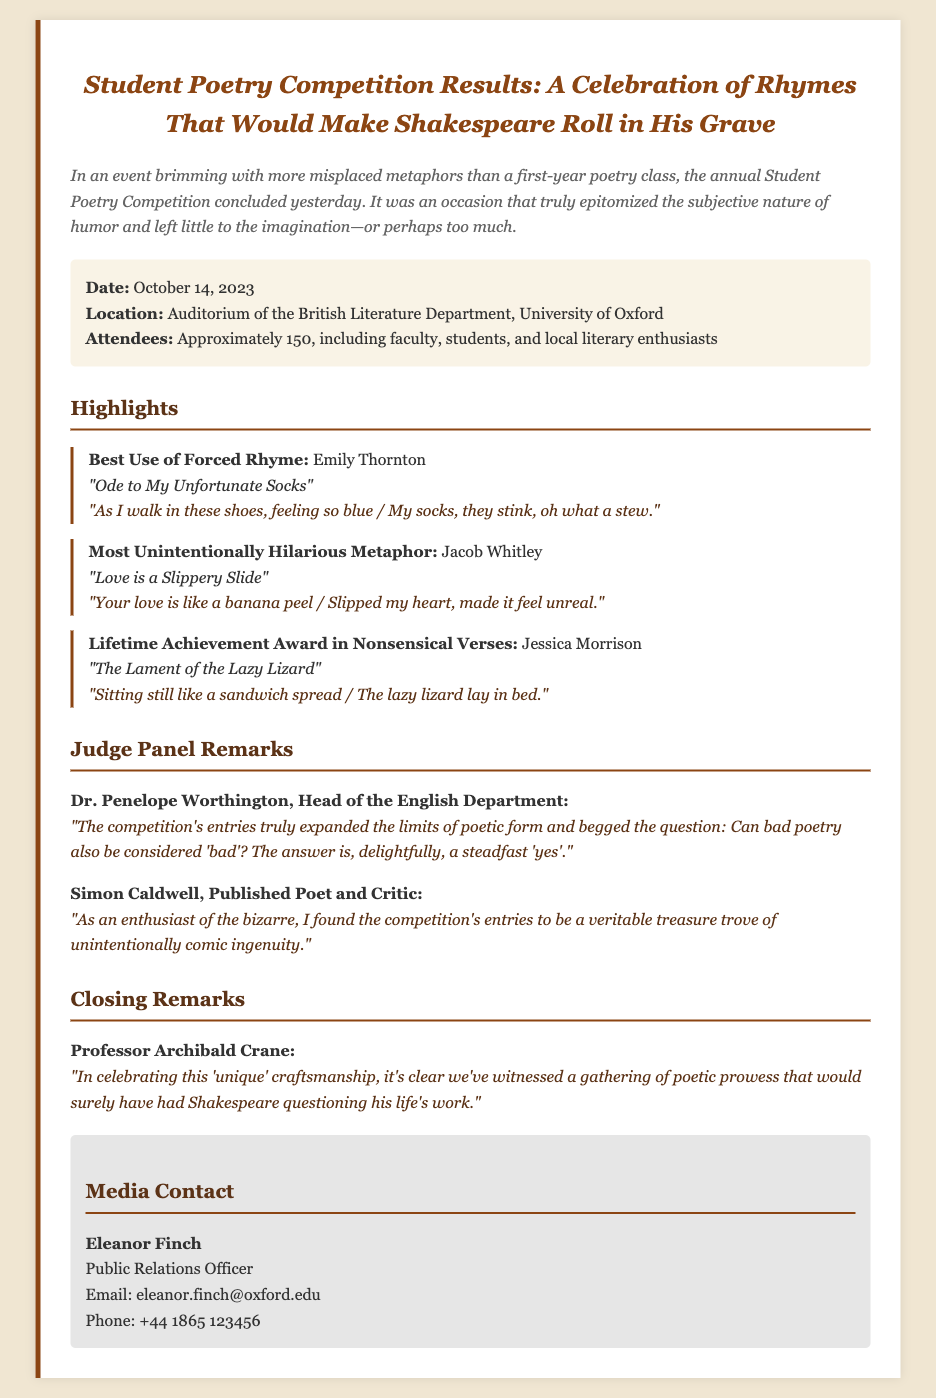What date did the competition take place? The date of the Student Poetry Competition is specifically mentioned in the document as October 14, 2023.
Answer: October 14, 2023 Who won the Best Use of Forced Rhyme award? The document provides the winner's name and the poem title for the Best Use of Forced Rhyme award, which is Emily Thornton for her poem.
Answer: Emily Thornton What metaphor was highlighted as the Most Unintentionally Hilarious? The document explicitly states the title of the poem that received this distinction, which is "Love is a Slippery Slide."
Answer: Love is a Slippery Slide How many attendees were at the event? The number of attendees is noted in the event details portion of the document, which is approximately 150.
Answer: Approximately 150 What is the primary theme of the competition, as indicated in the closing remarks? The closing remarks encapsulate the competition's essence and state that it involved a celebration of poetic creativity that might provoke questions about Shakespeare's own work.
Answer: Unique craftsmanship Who is the Public Relations Officer? The contact information section lists the name and title of the person responsible for media inquiries, which is Eleanor Finch.
Answer: Eleanor Finch What did Dr. Penelope Worthington say about bad poetry? The quote from Dr. Worthington in the document reflects on the nuances of bad poetry, stating that it can be considered 'bad.'
Answer: A steadfast 'yes' What is the genre of the competition? The document describes the type of competition as a poetry contest, indicated in the title and throughout the text.
Answer: Poetry Competition 